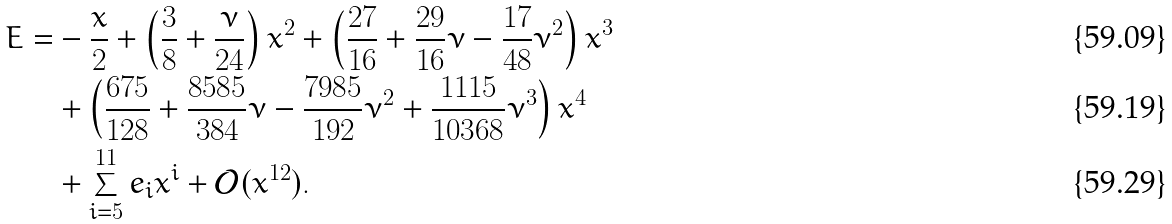<formula> <loc_0><loc_0><loc_500><loc_500>E = & - \frac { x } { 2 } + \left ( \frac { 3 } { 8 } + \frac { \nu } { 2 4 } \right ) x ^ { 2 } + \left ( \frac { 2 7 } { 1 6 } + \frac { 2 9 } { 1 6 } \nu - \frac { 1 7 } { 4 8 } \nu ^ { 2 } \right ) x ^ { 3 } \\ & + \left ( \frac { 6 7 5 } { 1 2 8 } + \frac { 8 5 8 5 } { 3 8 4 } \nu - \frac { 7 9 8 5 } { 1 9 2 } \nu ^ { 2 } + \frac { 1 1 1 5 } { 1 0 3 6 8 } \nu ^ { 3 } \right ) x ^ { 4 } \\ & + \sum _ { i = 5 } ^ { 1 1 } e _ { i } x ^ { i } + \mathcal { O } ( x ^ { 1 2 } ) .</formula> 